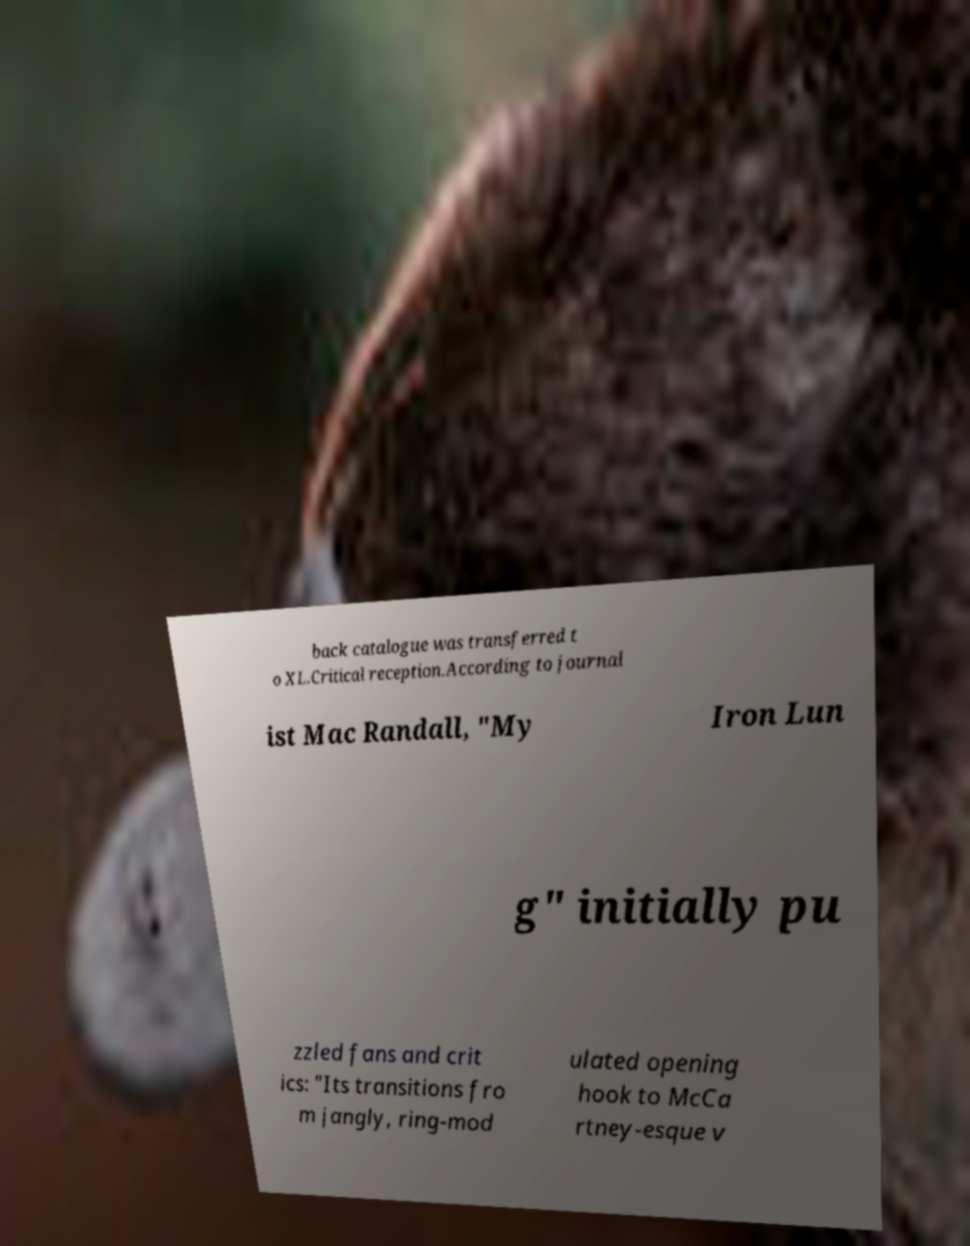Please identify and transcribe the text found in this image. back catalogue was transferred t o XL.Critical reception.According to journal ist Mac Randall, "My Iron Lun g" initially pu zzled fans and crit ics: "Its transitions fro m jangly, ring-mod ulated opening hook to McCa rtney-esque v 